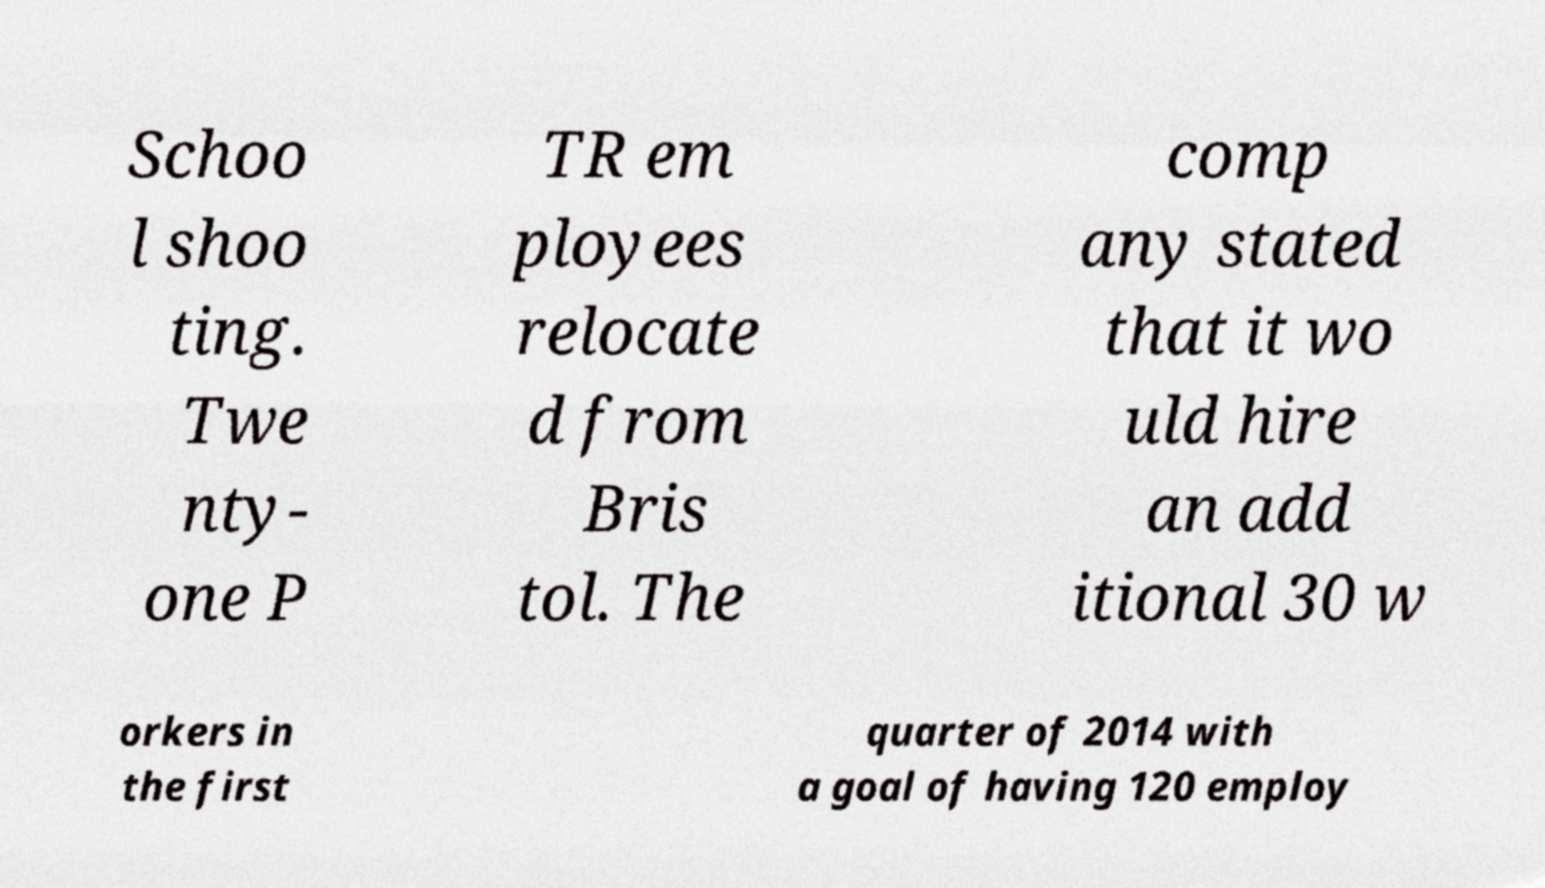Could you assist in decoding the text presented in this image and type it out clearly? Schoo l shoo ting. Twe nty- one P TR em ployees relocate d from Bris tol. The comp any stated that it wo uld hire an add itional 30 w orkers in the first quarter of 2014 with a goal of having 120 employ 